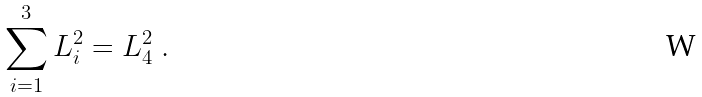<formula> <loc_0><loc_0><loc_500><loc_500>\sum _ { i = 1 } ^ { 3 } L _ { i } ^ { 2 } = L _ { 4 } ^ { 2 } \ .</formula> 